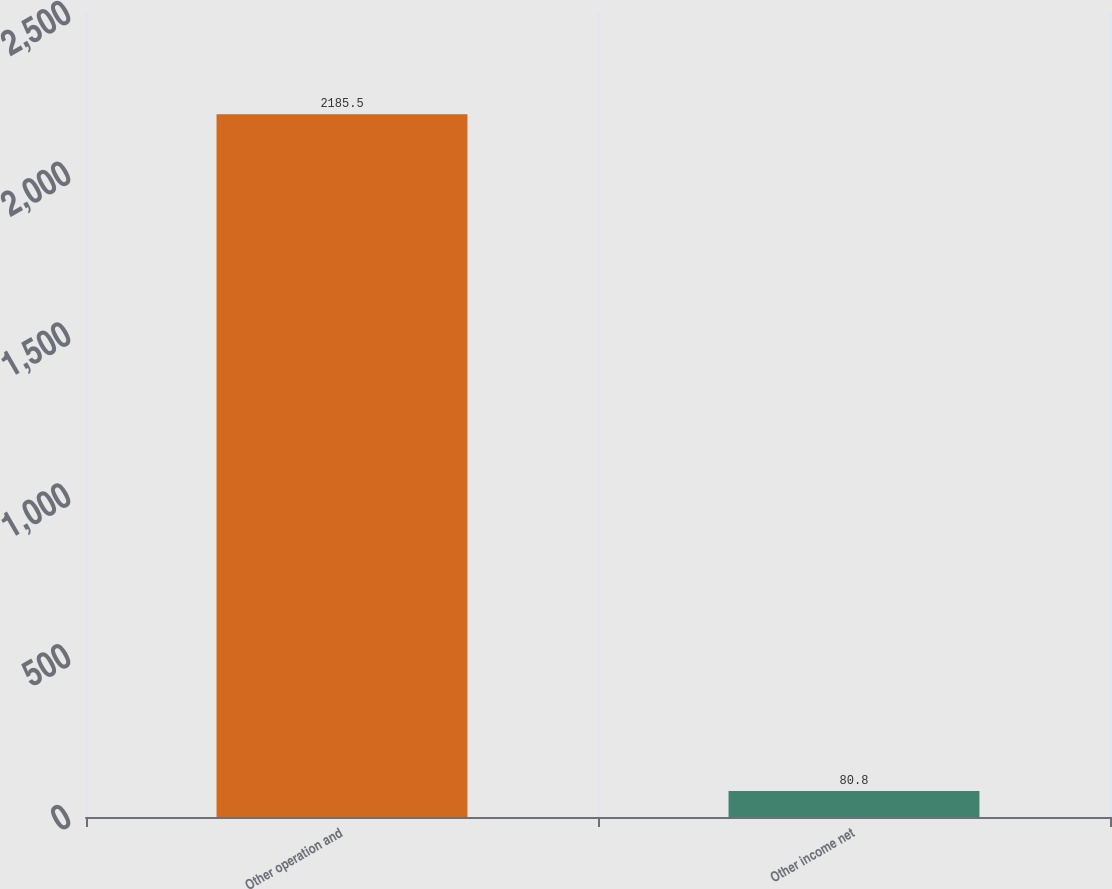<chart> <loc_0><loc_0><loc_500><loc_500><bar_chart><fcel>Other operation and<fcel>Other income net<nl><fcel>2185.5<fcel>80.8<nl></chart> 